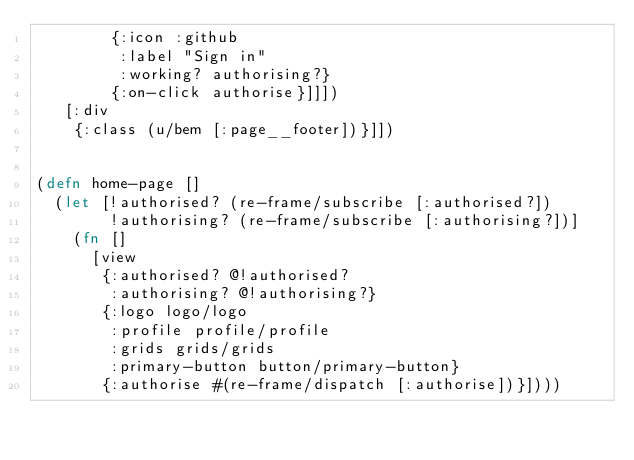Convert code to text. <code><loc_0><loc_0><loc_500><loc_500><_Clojure_>        {:icon :github
         :label "Sign in"
         :working? authorising?}
        {:on-click authorise}]]])
   [:div
    {:class (u/bem [:page__footer])}]])


(defn home-page []
  (let [!authorised? (re-frame/subscribe [:authorised?])
        !authorising? (re-frame/subscribe [:authorising?])]
    (fn []
      [view
       {:authorised? @!authorised?
        :authorising? @!authorising?}
       {:logo logo/logo
        :profile profile/profile
        :grids grids/grids
        :primary-button button/primary-button}
       {:authorise #(re-frame/dispatch [:authorise])}])))
</code> 